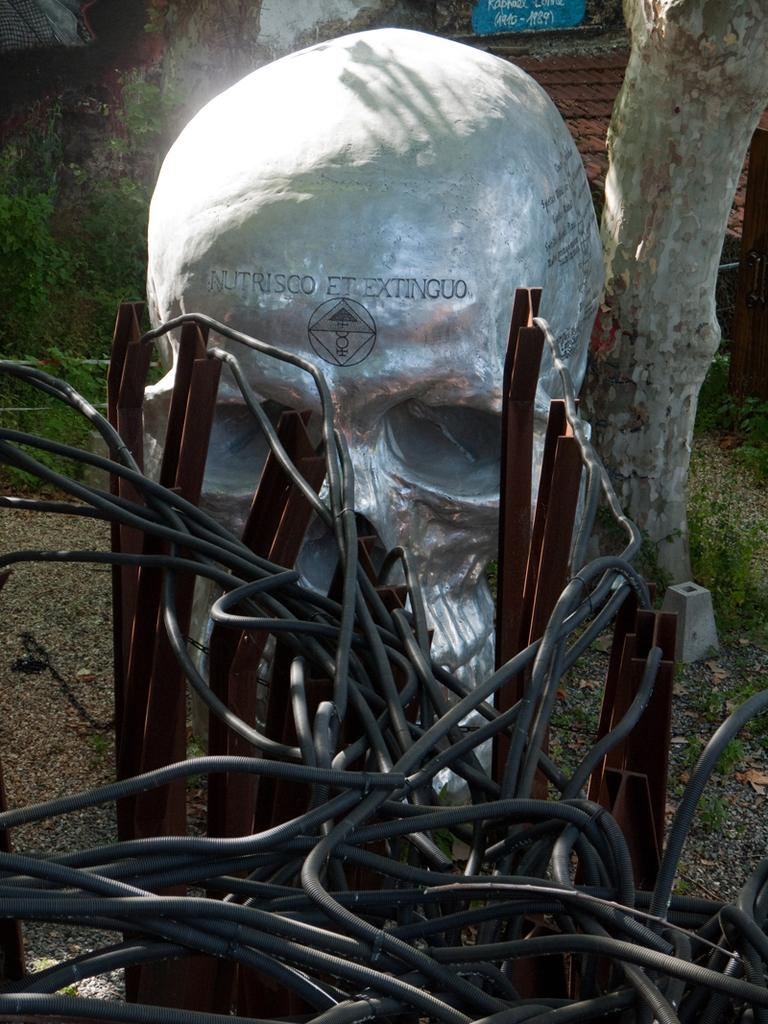What type of construction materials can be seen in the image? Cable wires and iron rods can be seen in the image. What is the main subject of the image? There is a sculpture of a person in the image. What natural element is present in the image? There is a stem of a tree in the image. How much money is being exchanged in the image? There is no exchange of money depicted in the image. What is the size of the number in the image? There are no numbers present in the image. 